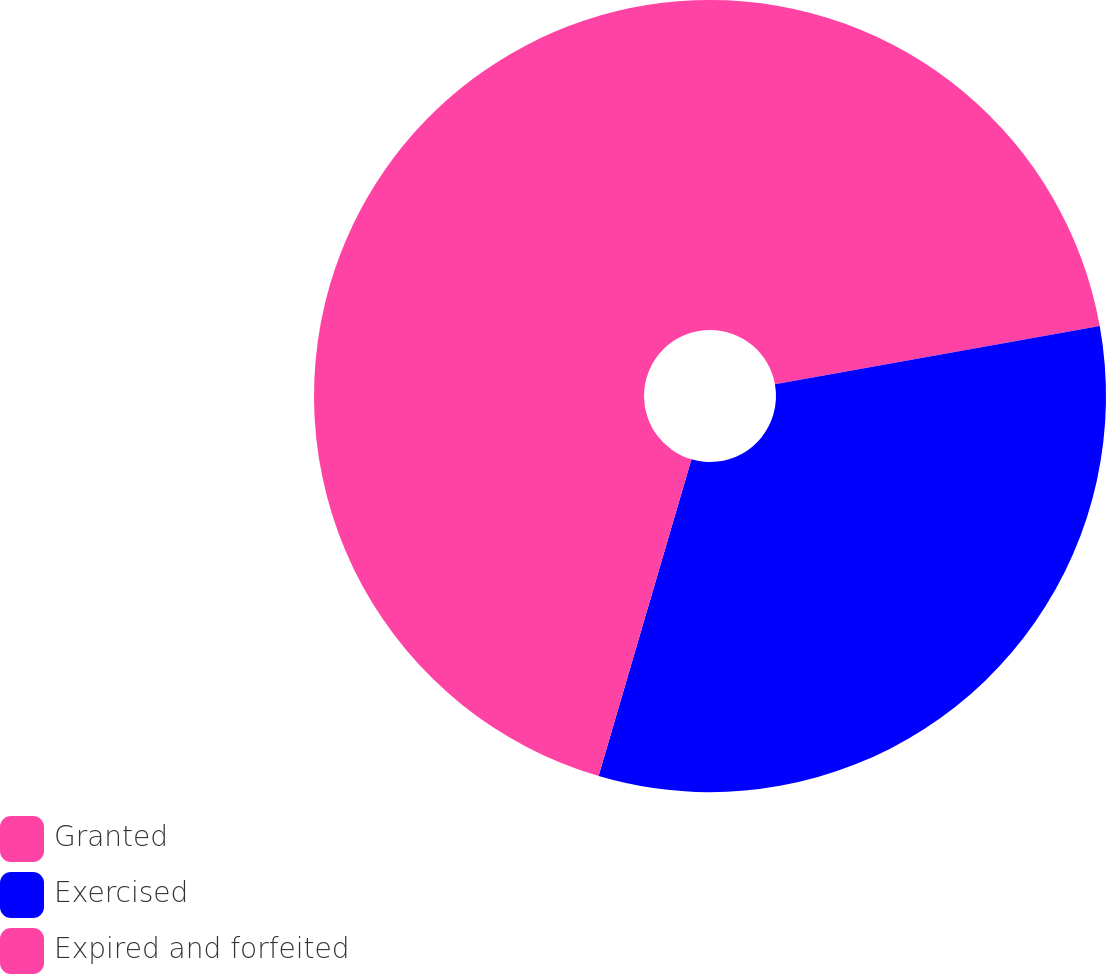Convert chart. <chart><loc_0><loc_0><loc_500><loc_500><pie_chart><fcel>Granted<fcel>Exercised<fcel>Expired and forfeited<nl><fcel>22.17%<fcel>32.37%<fcel>45.46%<nl></chart> 